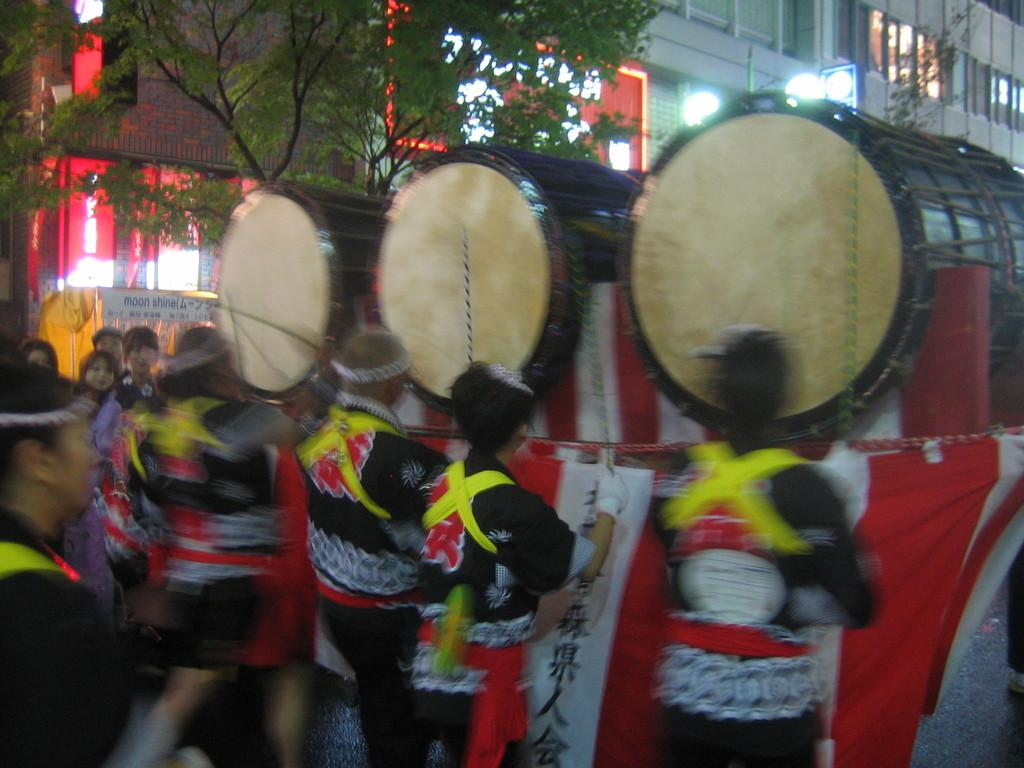What are the people in the image doing? The people in the image are playing music instruments. What can be seen in the background of the image? There is a tree and a building in the background of the image. What type of mass is being held in the image? There is no mass being held in the image; it features a group of people playing music instruments. What territory is depicted in the image? The image does not depict a specific territory; it shows a group of people playing music instruments with a tree and a building in the background. 